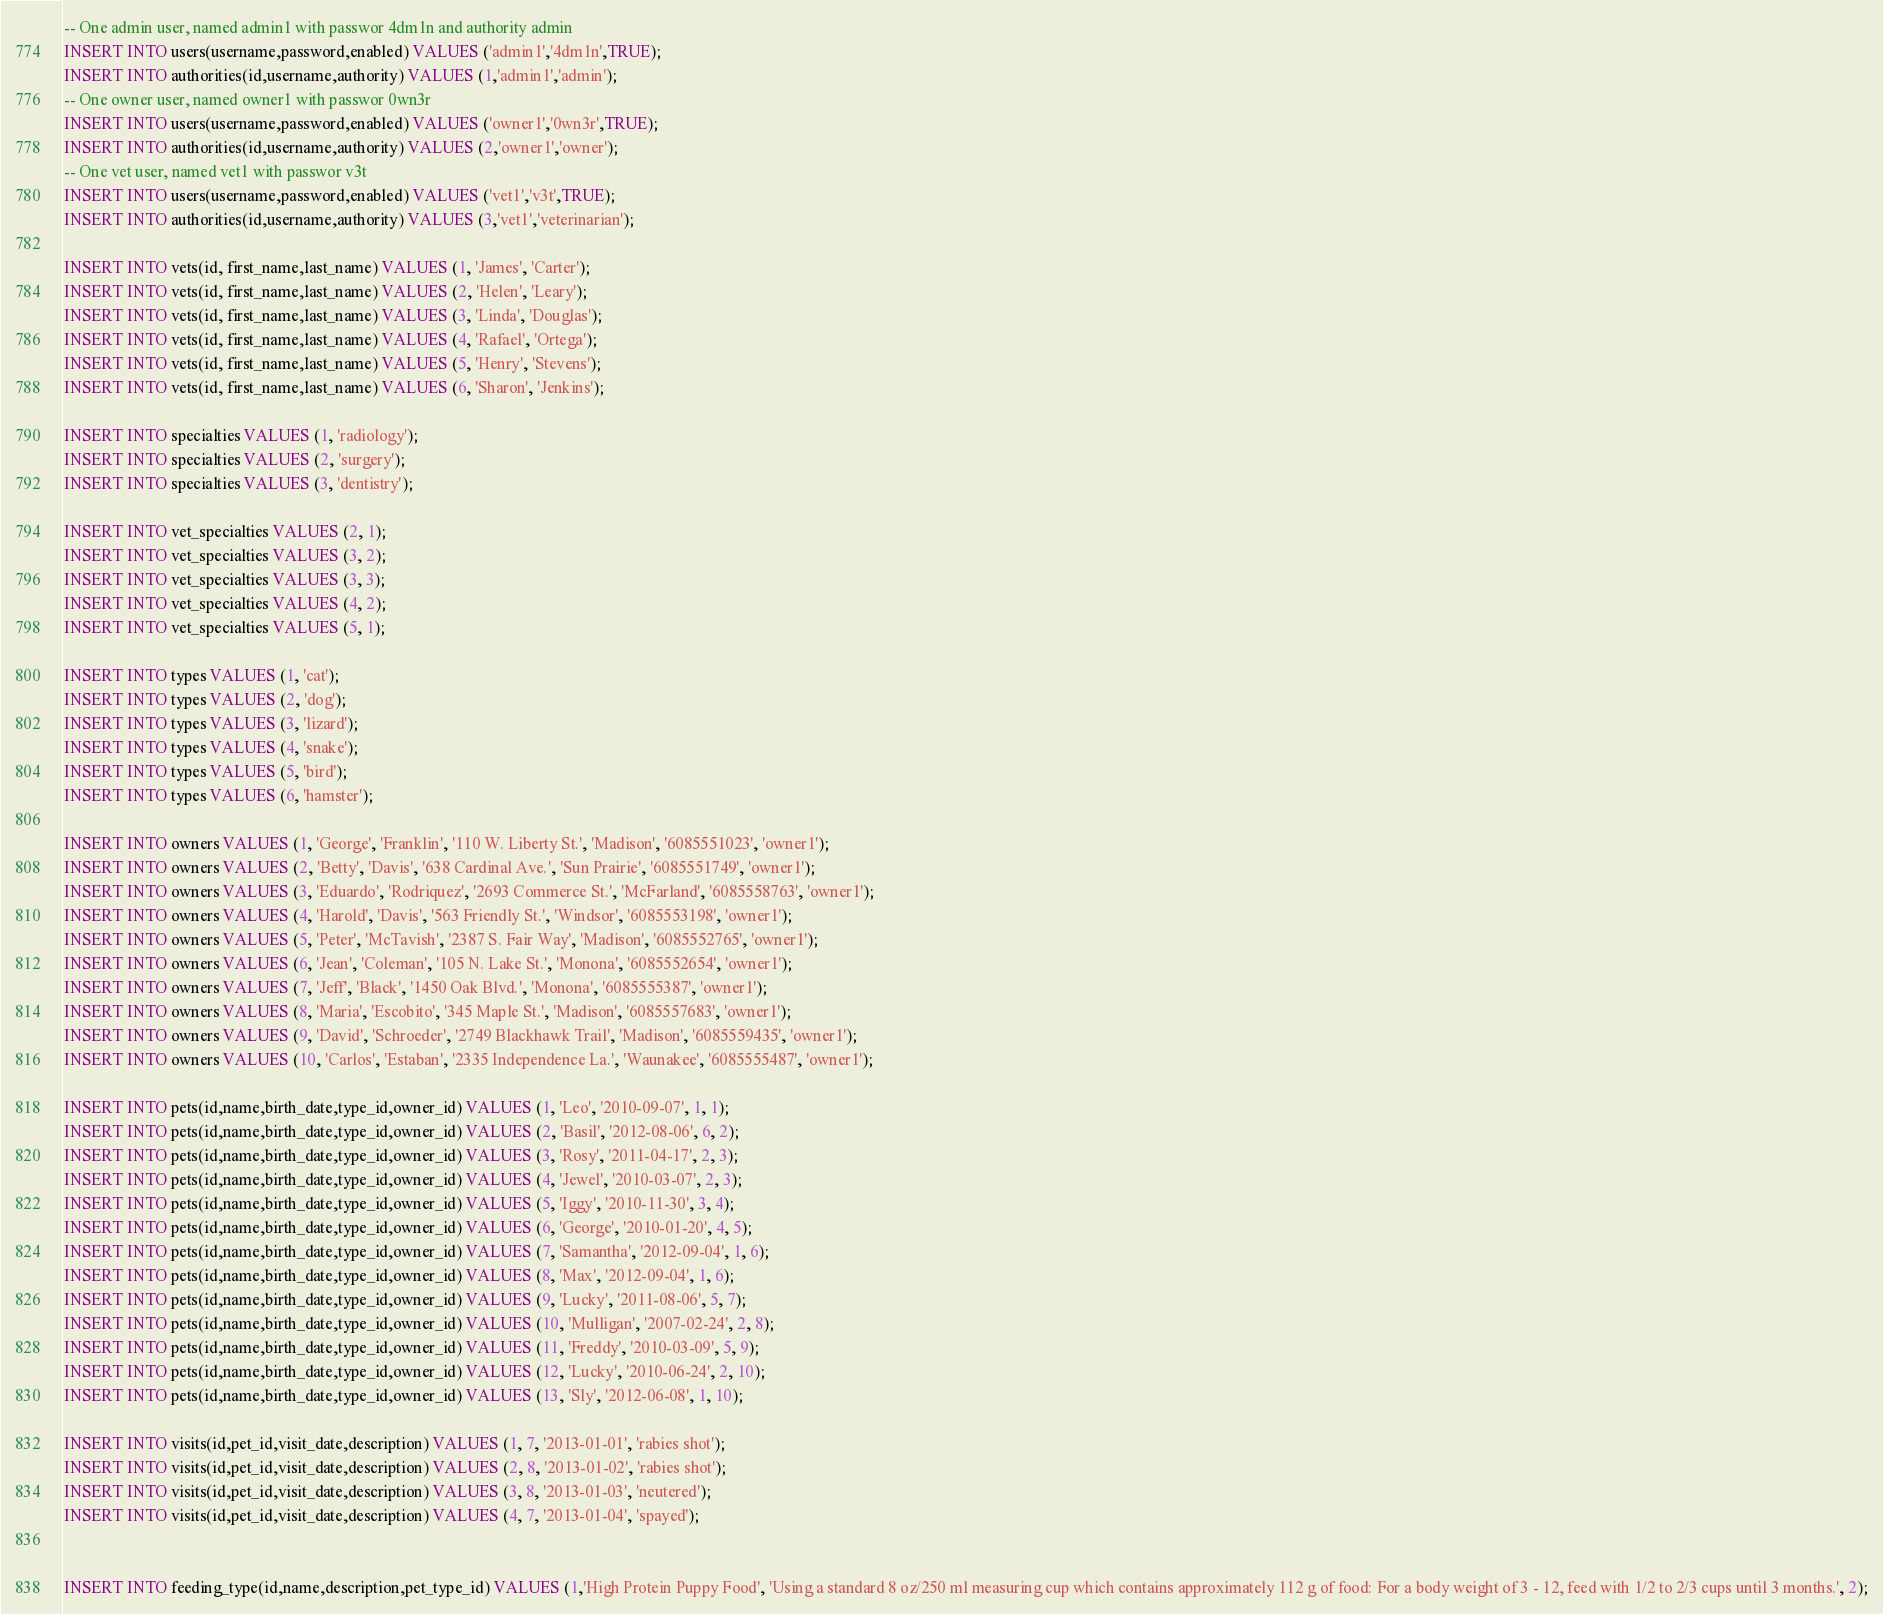Convert code to text. <code><loc_0><loc_0><loc_500><loc_500><_SQL_>-- One admin user, named admin1 with passwor 4dm1n and authority admin
INSERT INTO users(username,password,enabled) VALUES ('admin1','4dm1n',TRUE);
INSERT INTO authorities(id,username,authority) VALUES (1,'admin1','admin');
-- One owner user, named owner1 with passwor 0wn3r
INSERT INTO users(username,password,enabled) VALUES ('owner1','0wn3r',TRUE);
INSERT INTO authorities(id,username,authority) VALUES (2,'owner1','owner');
-- One vet user, named vet1 with passwor v3t
INSERT INTO users(username,password,enabled) VALUES ('vet1','v3t',TRUE);
INSERT INTO authorities(id,username,authority) VALUES (3,'vet1','veterinarian');

INSERT INTO vets(id, first_name,last_name) VALUES (1, 'James', 'Carter');
INSERT INTO vets(id, first_name,last_name) VALUES (2, 'Helen', 'Leary');
INSERT INTO vets(id, first_name,last_name) VALUES (3, 'Linda', 'Douglas');
INSERT INTO vets(id, first_name,last_name) VALUES (4, 'Rafael', 'Ortega');
INSERT INTO vets(id, first_name,last_name) VALUES (5, 'Henry', 'Stevens');
INSERT INTO vets(id, first_name,last_name) VALUES (6, 'Sharon', 'Jenkins');

INSERT INTO specialties VALUES (1, 'radiology');
INSERT INTO specialties VALUES (2, 'surgery');
INSERT INTO specialties VALUES (3, 'dentistry');

INSERT INTO vet_specialties VALUES (2, 1);
INSERT INTO vet_specialties VALUES (3, 2);
INSERT INTO vet_specialties VALUES (3, 3);
INSERT INTO vet_specialties VALUES (4, 2);
INSERT INTO vet_specialties VALUES (5, 1);

INSERT INTO types VALUES (1, 'cat');
INSERT INTO types VALUES (2, 'dog');
INSERT INTO types VALUES (3, 'lizard');
INSERT INTO types VALUES (4, 'snake');
INSERT INTO types VALUES (5, 'bird');
INSERT INTO types VALUES (6, 'hamster');

INSERT INTO owners VALUES (1, 'George', 'Franklin', '110 W. Liberty St.', 'Madison', '6085551023', 'owner1');
INSERT INTO owners VALUES (2, 'Betty', 'Davis', '638 Cardinal Ave.', 'Sun Prairie', '6085551749', 'owner1');
INSERT INTO owners VALUES (3, 'Eduardo', 'Rodriquez', '2693 Commerce St.', 'McFarland', '6085558763', 'owner1');
INSERT INTO owners VALUES (4, 'Harold', 'Davis', '563 Friendly St.', 'Windsor', '6085553198', 'owner1');
INSERT INTO owners VALUES (5, 'Peter', 'McTavish', '2387 S. Fair Way', 'Madison', '6085552765', 'owner1');
INSERT INTO owners VALUES (6, 'Jean', 'Coleman', '105 N. Lake St.', 'Monona', '6085552654', 'owner1');
INSERT INTO owners VALUES (7, 'Jeff', 'Black', '1450 Oak Blvd.', 'Monona', '6085555387', 'owner1');
INSERT INTO owners VALUES (8, 'Maria', 'Escobito', '345 Maple St.', 'Madison', '6085557683', 'owner1');
INSERT INTO owners VALUES (9, 'David', 'Schroeder', '2749 Blackhawk Trail', 'Madison', '6085559435', 'owner1');
INSERT INTO owners VALUES (10, 'Carlos', 'Estaban', '2335 Independence La.', 'Waunakee', '6085555487', 'owner1');

INSERT INTO pets(id,name,birth_date,type_id,owner_id) VALUES (1, 'Leo', '2010-09-07', 1, 1);
INSERT INTO pets(id,name,birth_date,type_id,owner_id) VALUES (2, 'Basil', '2012-08-06', 6, 2);
INSERT INTO pets(id,name,birth_date,type_id,owner_id) VALUES (3, 'Rosy', '2011-04-17', 2, 3);
INSERT INTO pets(id,name,birth_date,type_id,owner_id) VALUES (4, 'Jewel', '2010-03-07', 2, 3);
INSERT INTO pets(id,name,birth_date,type_id,owner_id) VALUES (5, 'Iggy', '2010-11-30', 3, 4);
INSERT INTO pets(id,name,birth_date,type_id,owner_id) VALUES (6, 'George', '2010-01-20', 4, 5);
INSERT INTO pets(id,name,birth_date,type_id,owner_id) VALUES (7, 'Samantha', '2012-09-04', 1, 6);
INSERT INTO pets(id,name,birth_date,type_id,owner_id) VALUES (8, 'Max', '2012-09-04', 1, 6);
INSERT INTO pets(id,name,birth_date,type_id,owner_id) VALUES (9, 'Lucky', '2011-08-06', 5, 7);
INSERT INTO pets(id,name,birth_date,type_id,owner_id) VALUES (10, 'Mulligan', '2007-02-24', 2, 8);
INSERT INTO pets(id,name,birth_date,type_id,owner_id) VALUES (11, 'Freddy', '2010-03-09', 5, 9);
INSERT INTO pets(id,name,birth_date,type_id,owner_id) VALUES (12, 'Lucky', '2010-06-24', 2, 10);
INSERT INTO pets(id,name,birth_date,type_id,owner_id) VALUES (13, 'Sly', '2012-06-08', 1, 10);

INSERT INTO visits(id,pet_id,visit_date,description) VALUES (1, 7, '2013-01-01', 'rabies shot');
INSERT INTO visits(id,pet_id,visit_date,description) VALUES (2, 8, '2013-01-02', 'rabies shot');
INSERT INTO visits(id,pet_id,visit_date,description) VALUES (3, 8, '2013-01-03', 'neutered');
INSERT INTO visits(id,pet_id,visit_date,description) VALUES (4, 7, '2013-01-04', 'spayed');


INSERT INTO feeding_type(id,name,description,pet_type_id) VALUES (1,'High Protein Puppy Food', 'Using a standard 8 oz/250 ml measuring cup which contains approximately 112 g of food: For a body weight of 3 - 12, feed with 1/2 to 2/3 cups until 3 months.', 2);</code> 